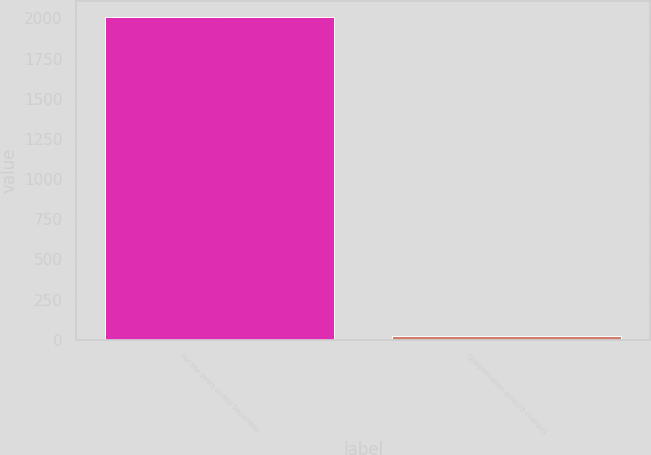Convert chart. <chart><loc_0><loc_0><loc_500><loc_500><bar_chart><fcel>For the years ended December<fcel>Compensation amount charged<nl><fcel>2007<fcel>26.8<nl></chart> 